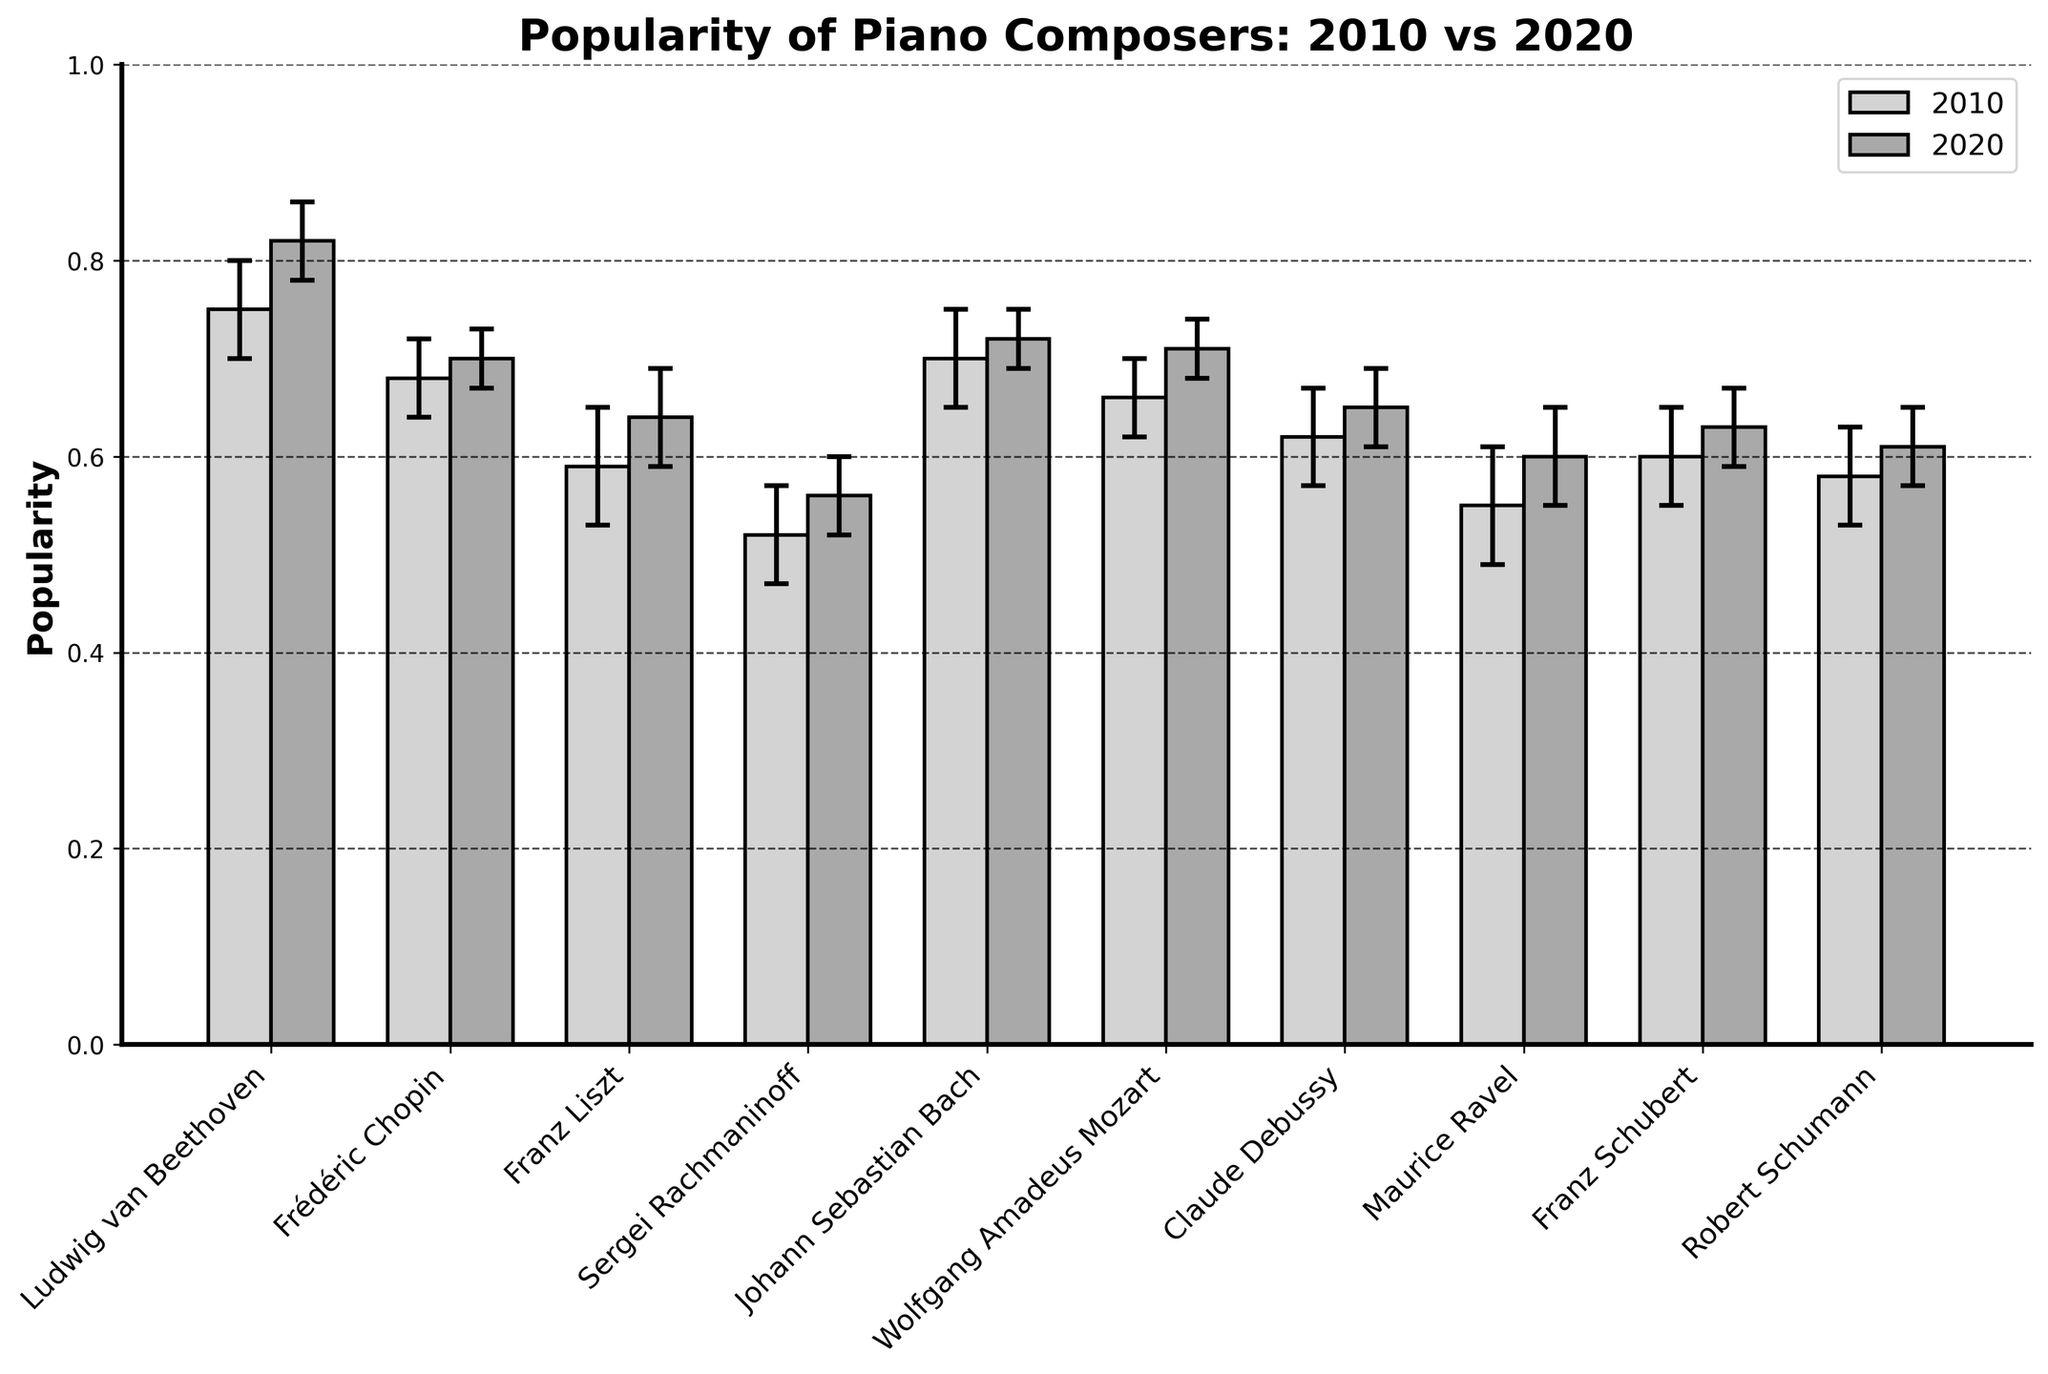What is the title of the figure? The title of a figure is usually placed at the top and indicates what the figure is about.
Answer: Popularity of Piano Composers: 2010 vs 2020 How many composers are compared in the figure? By counting the number of unique names on the x-axis, we can determine the number of composers.
Answer: Ten What is the maximum popularity score recorded in 2020 and for which composer? Identify the highest bar for the 2020 data and note the corresponding composer.
Answer: 0.82, Ludwig van Beethoven Which composer had the least confidence interval for popularity in 2020? Confidence intervals are represented by error bars; the shortest error bar in 2020 indicates the least confidence interval, aligning it with the composer.
Answer: Frédéric Chopin How did the popularity of Claude Debussy change from 2010 to 2020? Locate the bars corresponding to Claude Debussy and compare their heights for 2010 and 2020.
Answer: Increased from 0.62 to 0.65 Which composers’ popularity increased from 2010 to 2020? Compare the height of the bars for 2010 and 2020 for each composer to see which ones have higher values in 2020.
Answer: Ludwig van Beethoven, Frédéric Chopin, Franz Liszt, Sergei Rachmaninoff, Johann Sebastian Bach, Wolfgang Amadeus Mozart, Claude Debussy, Maurice Ravel, Franz Schubert, Robert Schumann Which composer had the largest increase in popularity from 2010 to 2020? Find the difference in popularity for each composer between 2020 and 2010, and identify the composer with the largest difference.
Answer: Ludwig van Beethoven What is the average popularity of all composers in 2020? Sum the popularity values for 2020 and divide by the number of composers. Calculations: (0.82 + 0.70 + 0.64 + 0.56 + 0.72 + 0.71 + 0.65 + 0.60 + 0.63 + 0.61) / 10 = 6.44 / 10.
Answer: 0.644 Between Johann Sebastian Bach and Wolfgang Amadeus Mozart, who had a higher popularity in 2010? Compare the heights of the 2010 bars for these two composers.
Answer: Johann Sebastian Bach 